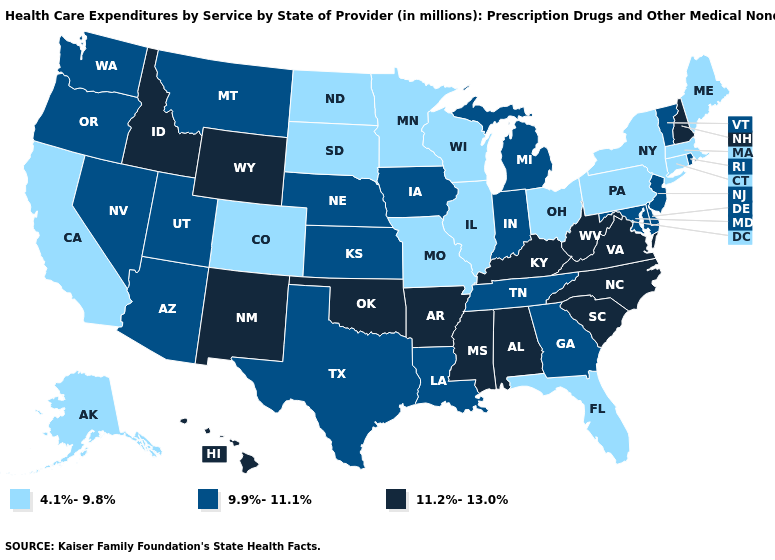What is the value of Ohio?
Keep it brief. 4.1%-9.8%. Among the states that border West Virginia , which have the lowest value?
Write a very short answer. Ohio, Pennsylvania. What is the value of Indiana?
Keep it brief. 9.9%-11.1%. Name the states that have a value in the range 4.1%-9.8%?
Keep it brief. Alaska, California, Colorado, Connecticut, Florida, Illinois, Maine, Massachusetts, Minnesota, Missouri, New York, North Dakota, Ohio, Pennsylvania, South Dakota, Wisconsin. What is the value of Maryland?
Write a very short answer. 9.9%-11.1%. Does North Dakota have the lowest value in the MidWest?
Concise answer only. Yes. Name the states that have a value in the range 9.9%-11.1%?
Answer briefly. Arizona, Delaware, Georgia, Indiana, Iowa, Kansas, Louisiana, Maryland, Michigan, Montana, Nebraska, Nevada, New Jersey, Oregon, Rhode Island, Tennessee, Texas, Utah, Vermont, Washington. Does New York have the same value as California?
Write a very short answer. Yes. Name the states that have a value in the range 4.1%-9.8%?
Concise answer only. Alaska, California, Colorado, Connecticut, Florida, Illinois, Maine, Massachusetts, Minnesota, Missouri, New York, North Dakota, Ohio, Pennsylvania, South Dakota, Wisconsin. What is the highest value in the MidWest ?
Quick response, please. 9.9%-11.1%. Which states have the lowest value in the MidWest?
Short answer required. Illinois, Minnesota, Missouri, North Dakota, Ohio, South Dakota, Wisconsin. Which states have the highest value in the USA?
Write a very short answer. Alabama, Arkansas, Hawaii, Idaho, Kentucky, Mississippi, New Hampshire, New Mexico, North Carolina, Oklahoma, South Carolina, Virginia, West Virginia, Wyoming. Does Delaware have the same value as Oklahoma?
Give a very brief answer. No. What is the value of Idaho?
Give a very brief answer. 11.2%-13.0%. Does the first symbol in the legend represent the smallest category?
Write a very short answer. Yes. 